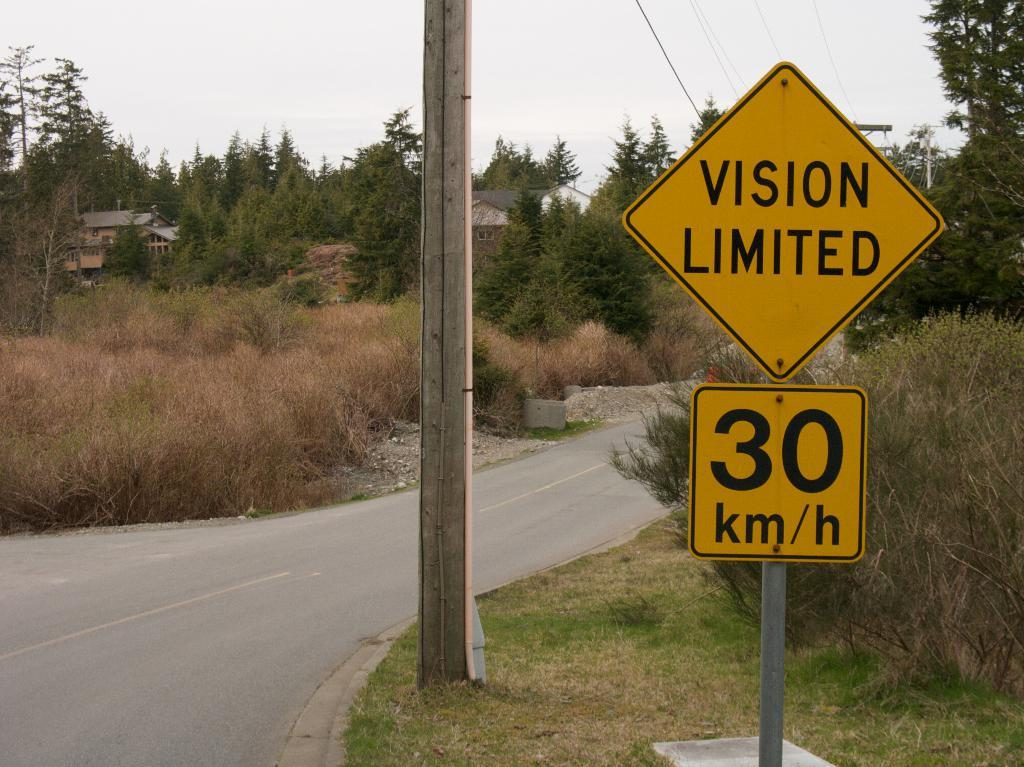<image>
Summarize the visual content of the image. Two yellow signs on an empty street with one saying 30 km/h. 